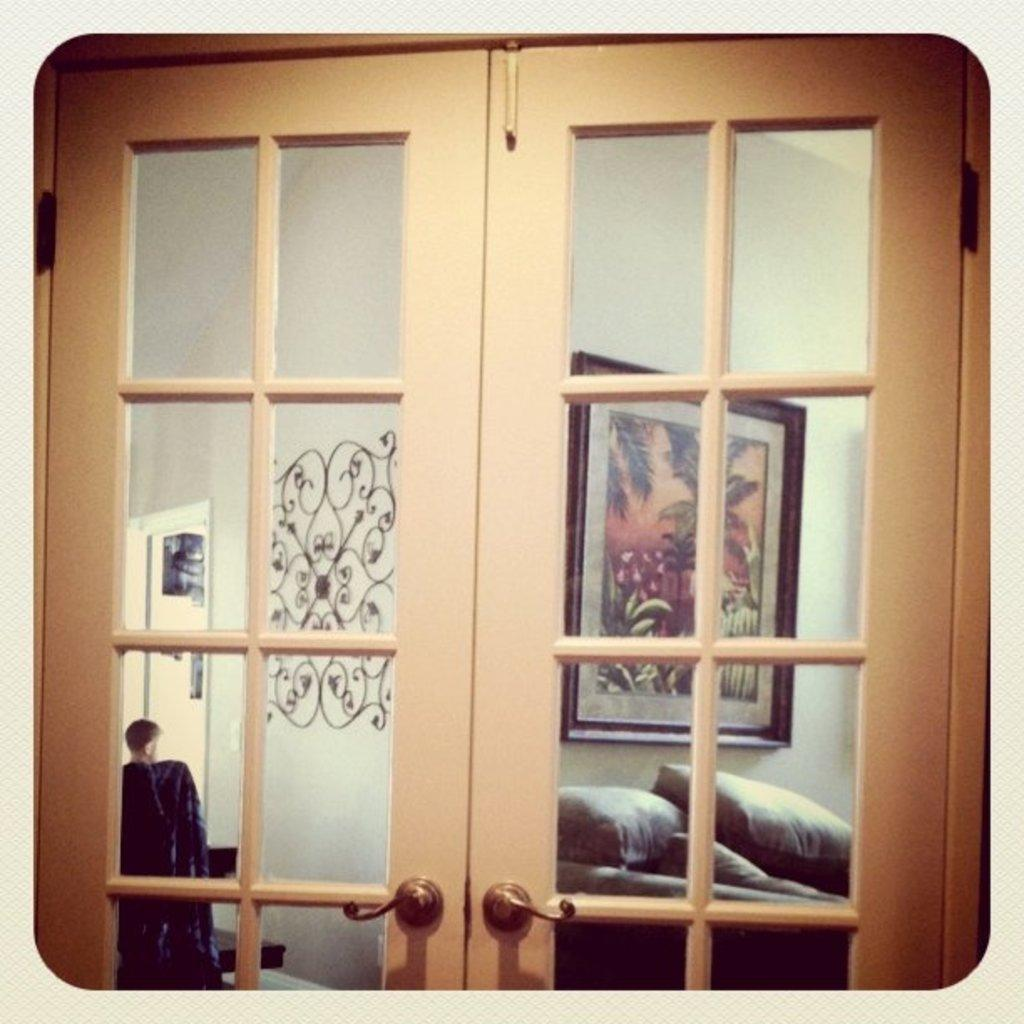What type of door is visible in the image? There is a glass door in the image. Who or what is behind the glass door? A person is standing behind the glass door. What type of furniture or accessory can be seen in the image? There are pillows visible in the image. What is the frame in the image used for? The frame in the image is likely used for displaying the painting on the wall. What type of army is depicted in the painting on the wall? There is no army depicted in the painting on the wall; it is not mentioned in the provided facts. 